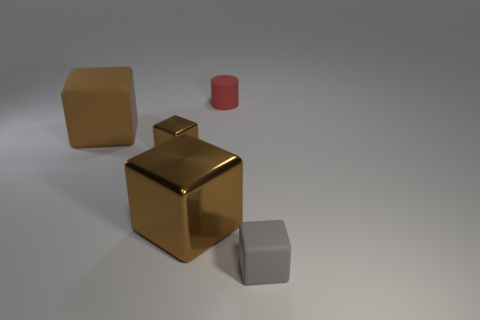How many brown cubes must be subtracted to get 1 brown cubes? 2 Add 1 blocks. How many objects exist? 6 Subtract all gray blocks. How many blocks are left? 3 Subtract all large metal cubes. How many cubes are left? 3 Subtract 3 blocks. How many blocks are left? 1 Subtract 0 brown spheres. How many objects are left? 5 Subtract all cylinders. How many objects are left? 4 Subtract all gray cylinders. Subtract all red blocks. How many cylinders are left? 1 Subtract all cyan balls. How many yellow cylinders are left? 0 Subtract all small metal objects. Subtract all red cylinders. How many objects are left? 3 